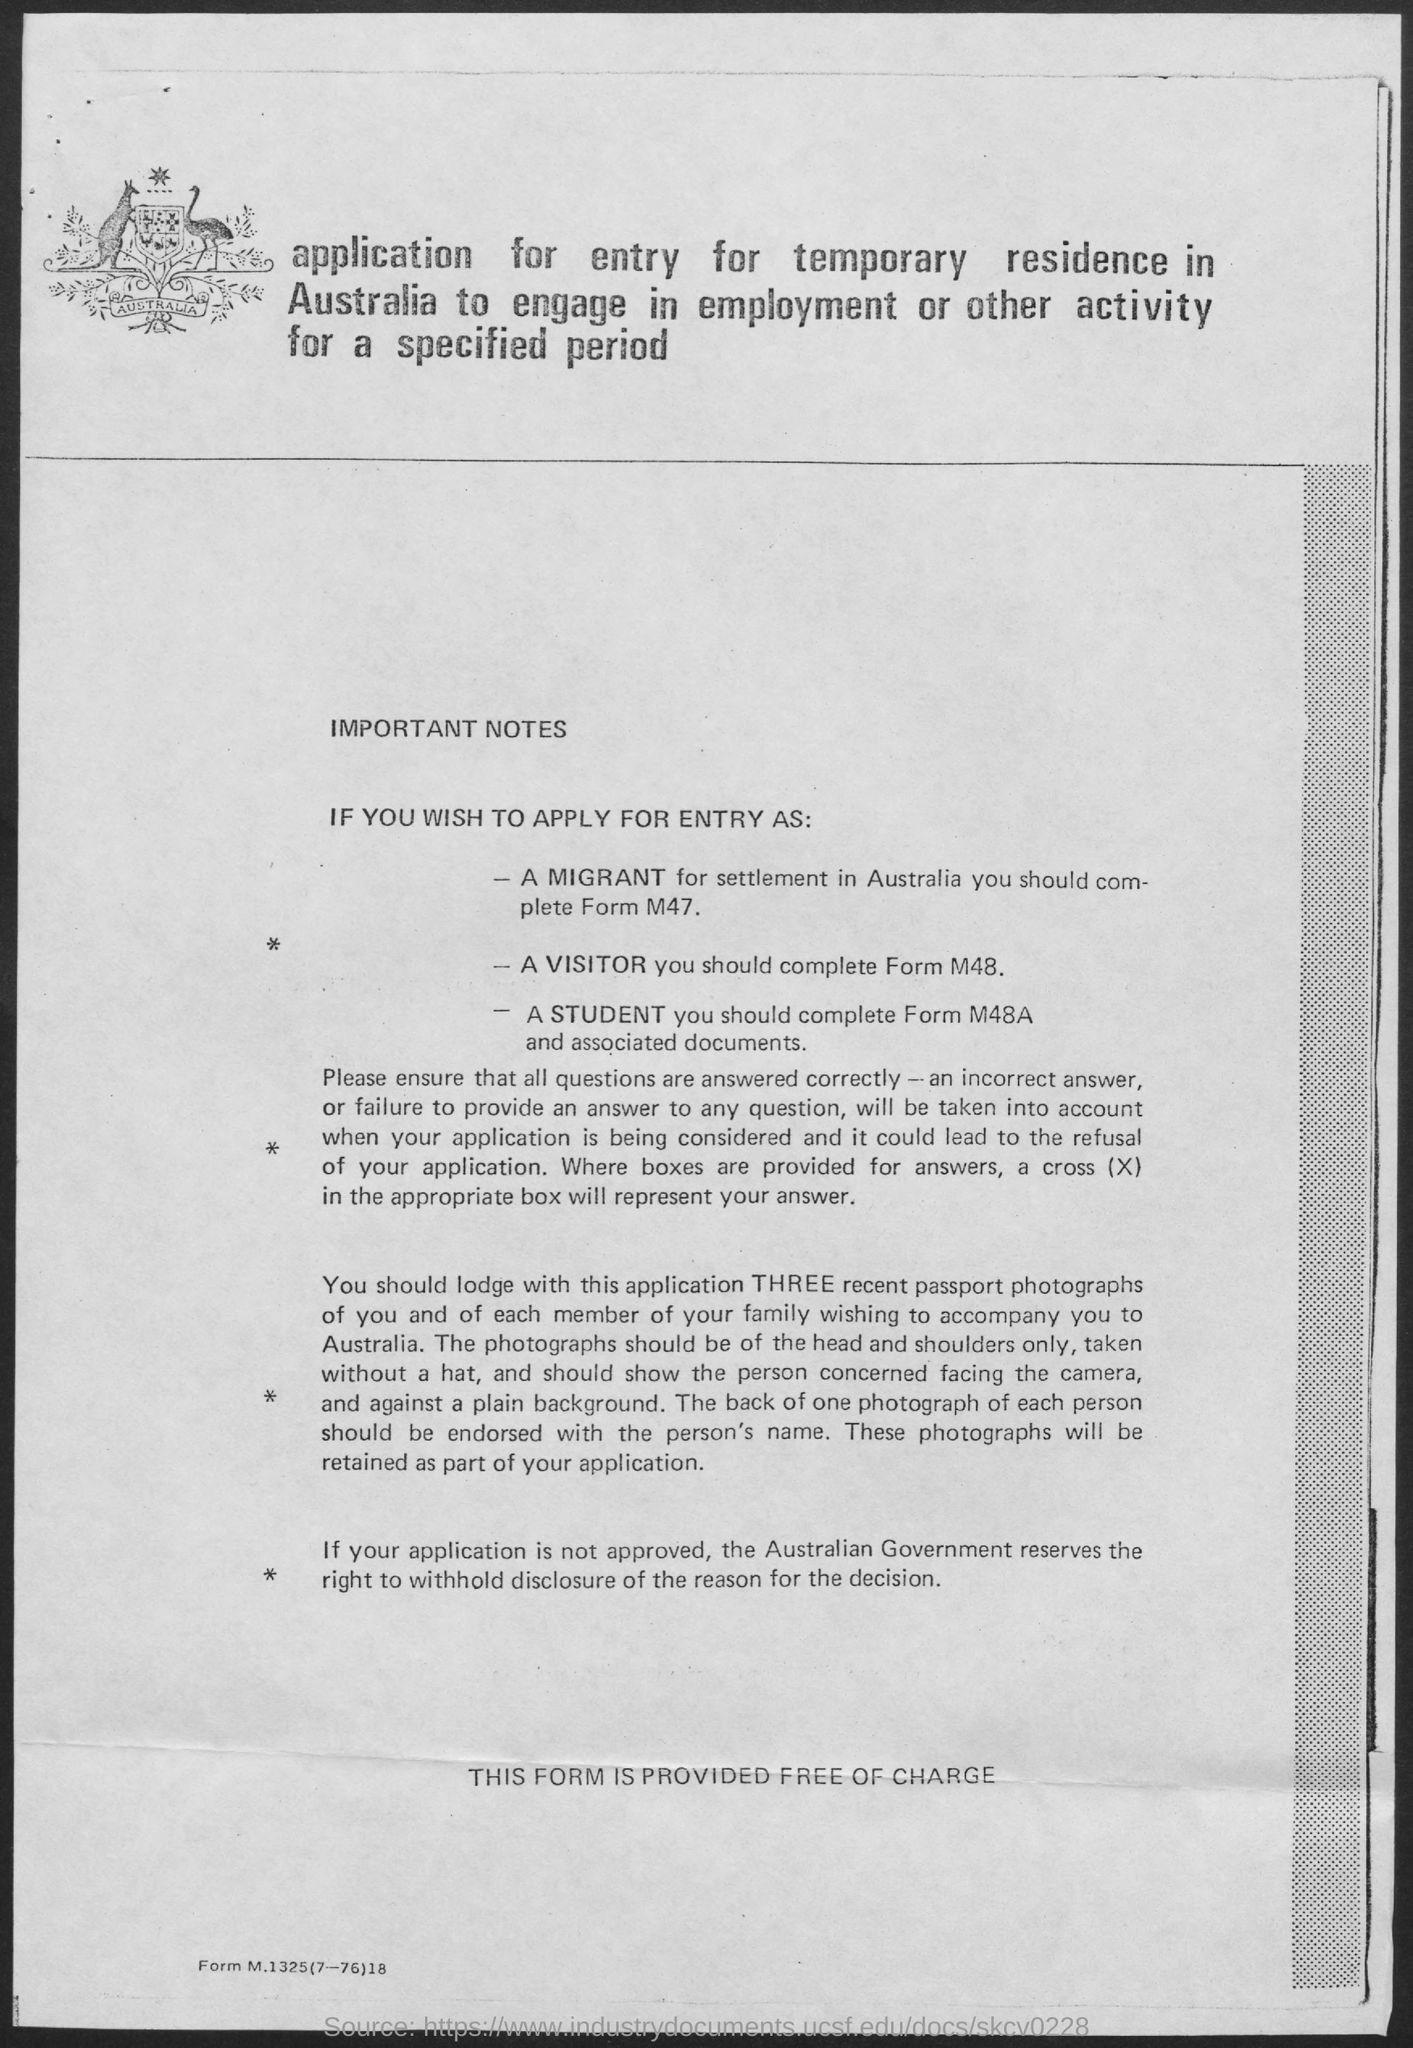Which form should be completed by a migrant??
Make the answer very short. M47. Which form should be completed by a Visitor??
Your answer should be compact. M48. What is the Cost of the form?
Provide a succinct answer. Free of charge. 